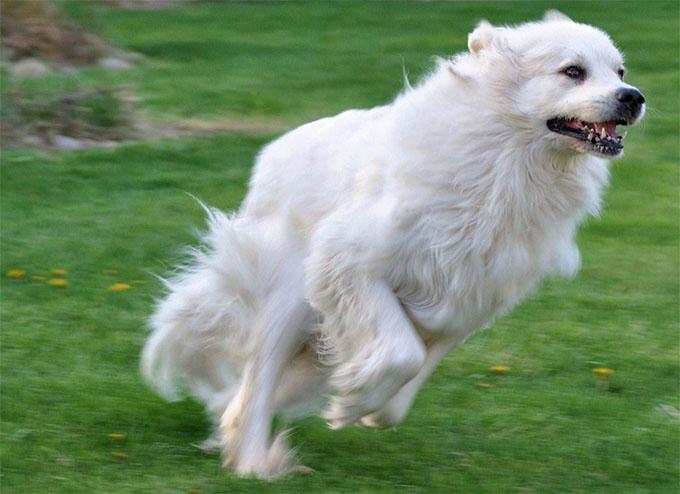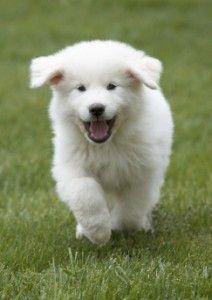The first image is the image on the left, the second image is the image on the right. Examine the images to the left and right. Is the description "In at least one of the images, a white dog is laying down in grass" accurate? Answer yes or no. No. The first image is the image on the left, the second image is the image on the right. For the images shown, is this caption "The right image contains one white dog that is laying down in the grass." true? Answer yes or no. No. 